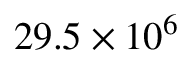Convert formula to latex. <formula><loc_0><loc_0><loc_500><loc_500>2 9 . 5 \times 1 0 ^ { 6 }</formula> 